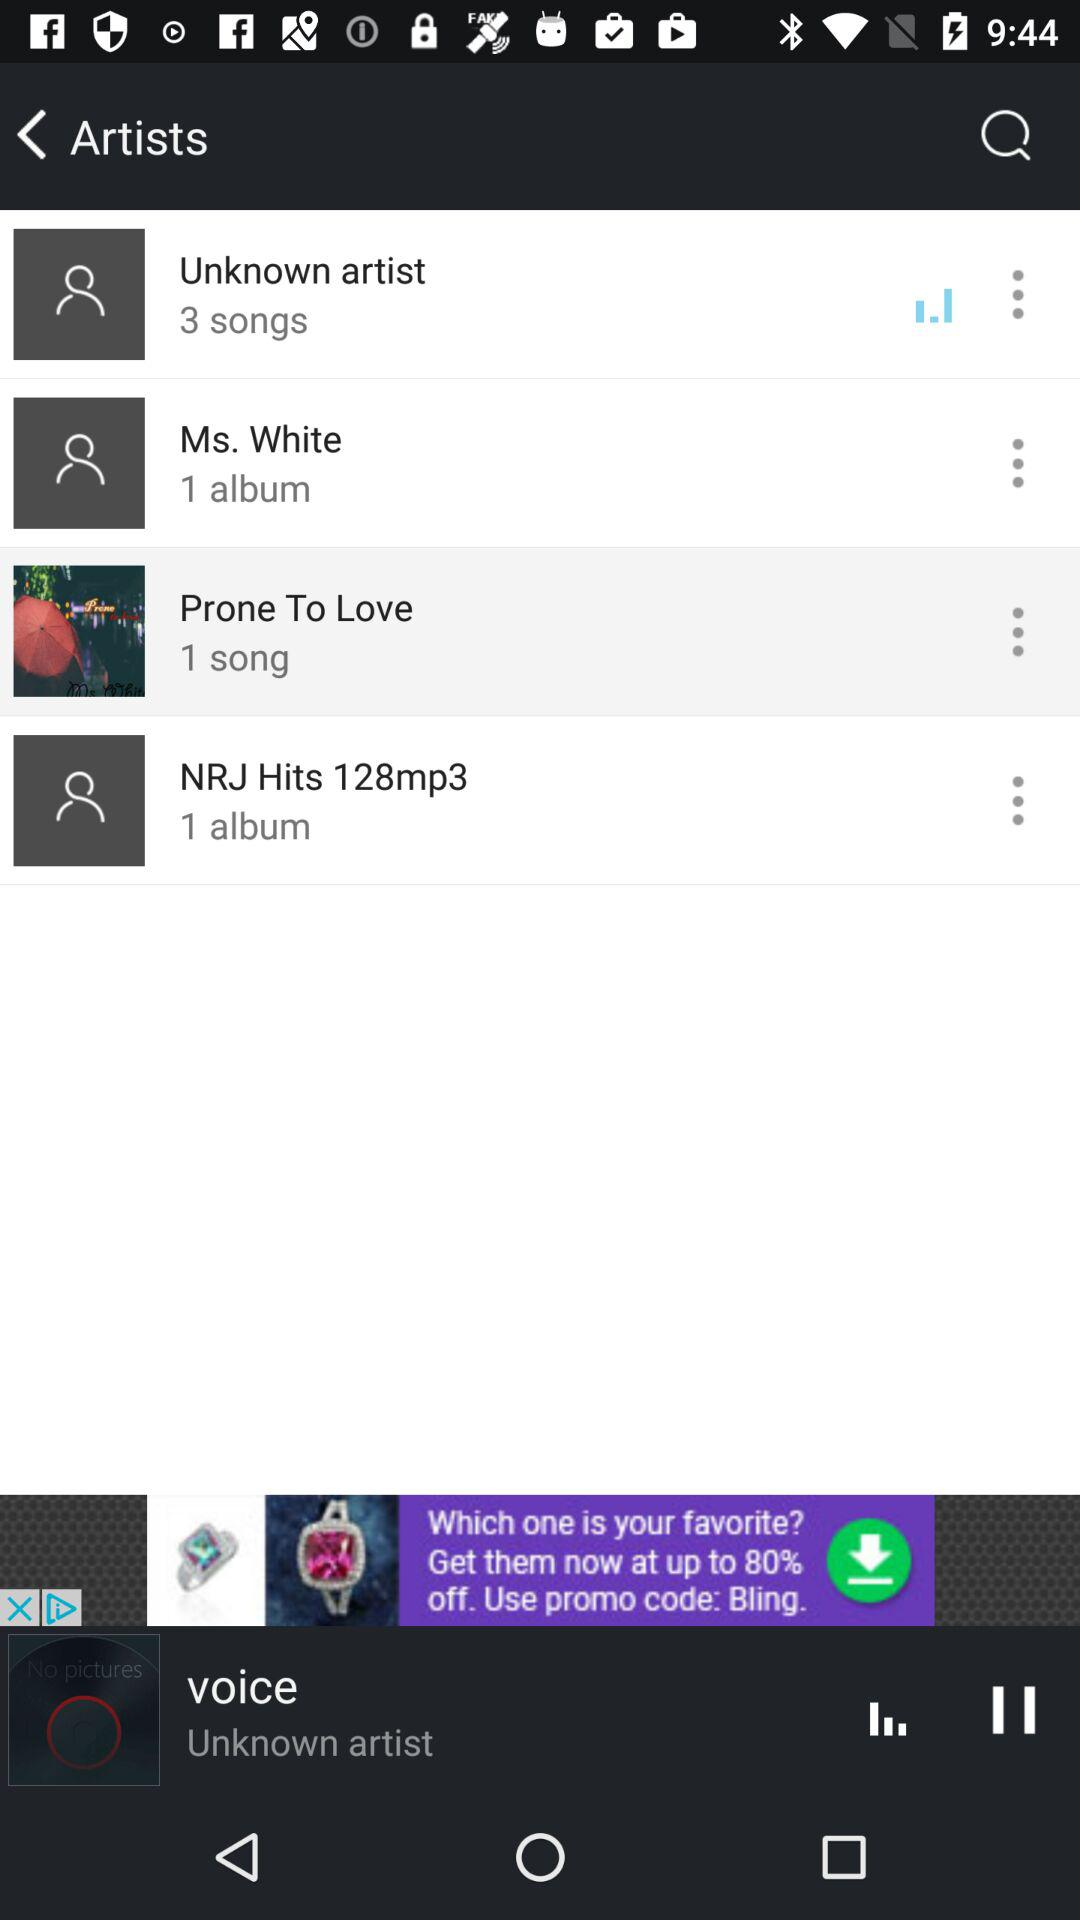How many songs are there by the unknown artist? The number of songs is 3. 